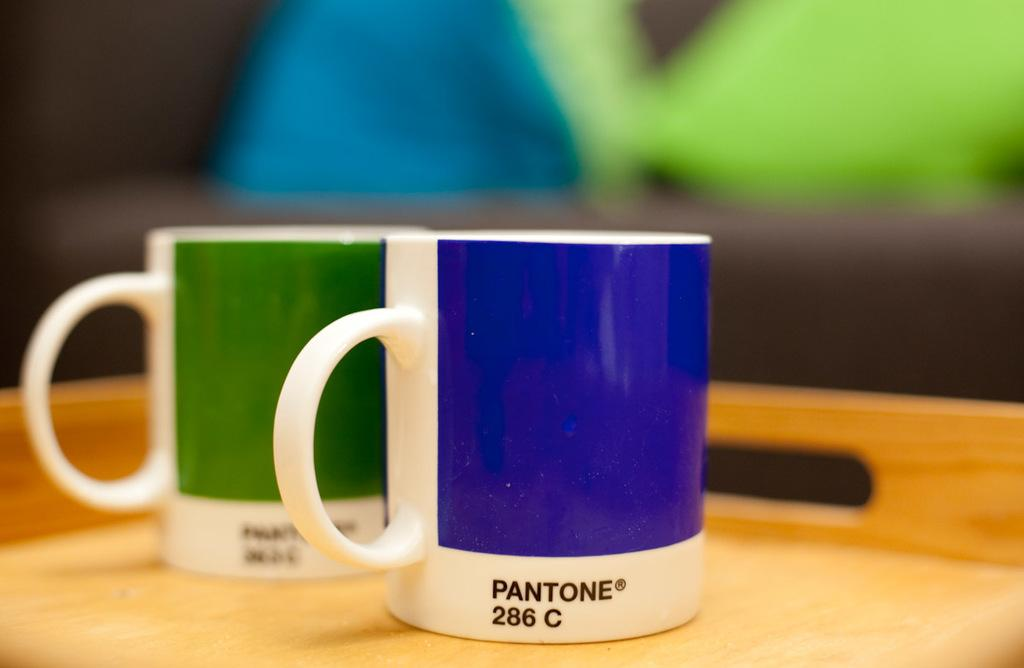<image>
Present a compact description of the photo's key features. A green and a blue coffee mug show Pantone colors. 